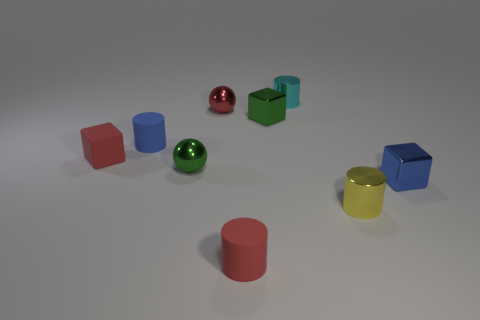How many small red metallic things are the same shape as the tiny yellow metal thing?
Give a very brief answer. 0. The tiny cube that is on the right side of the red metal sphere and on the left side of the small yellow object is made of what material?
Offer a terse response. Metal. What number of tiny cubes are to the right of the red shiny object?
Offer a terse response. 2. What number of big blue cylinders are there?
Keep it short and to the point. 0. Do the blue matte object and the red metallic thing have the same size?
Provide a short and direct response. Yes. Are there any tiny cyan cylinders in front of the tiny blue object right of the small shiny cylinder behind the green shiny cube?
Provide a short and direct response. No. What material is the tiny red object that is the same shape as the small blue rubber object?
Your answer should be very brief. Rubber. The metal block that is behind the blue rubber thing is what color?
Give a very brief answer. Green. The yellow shiny object is what size?
Provide a succinct answer. Small. Do the red cylinder and the shiny cylinder to the right of the cyan metallic cylinder have the same size?
Keep it short and to the point. Yes. 